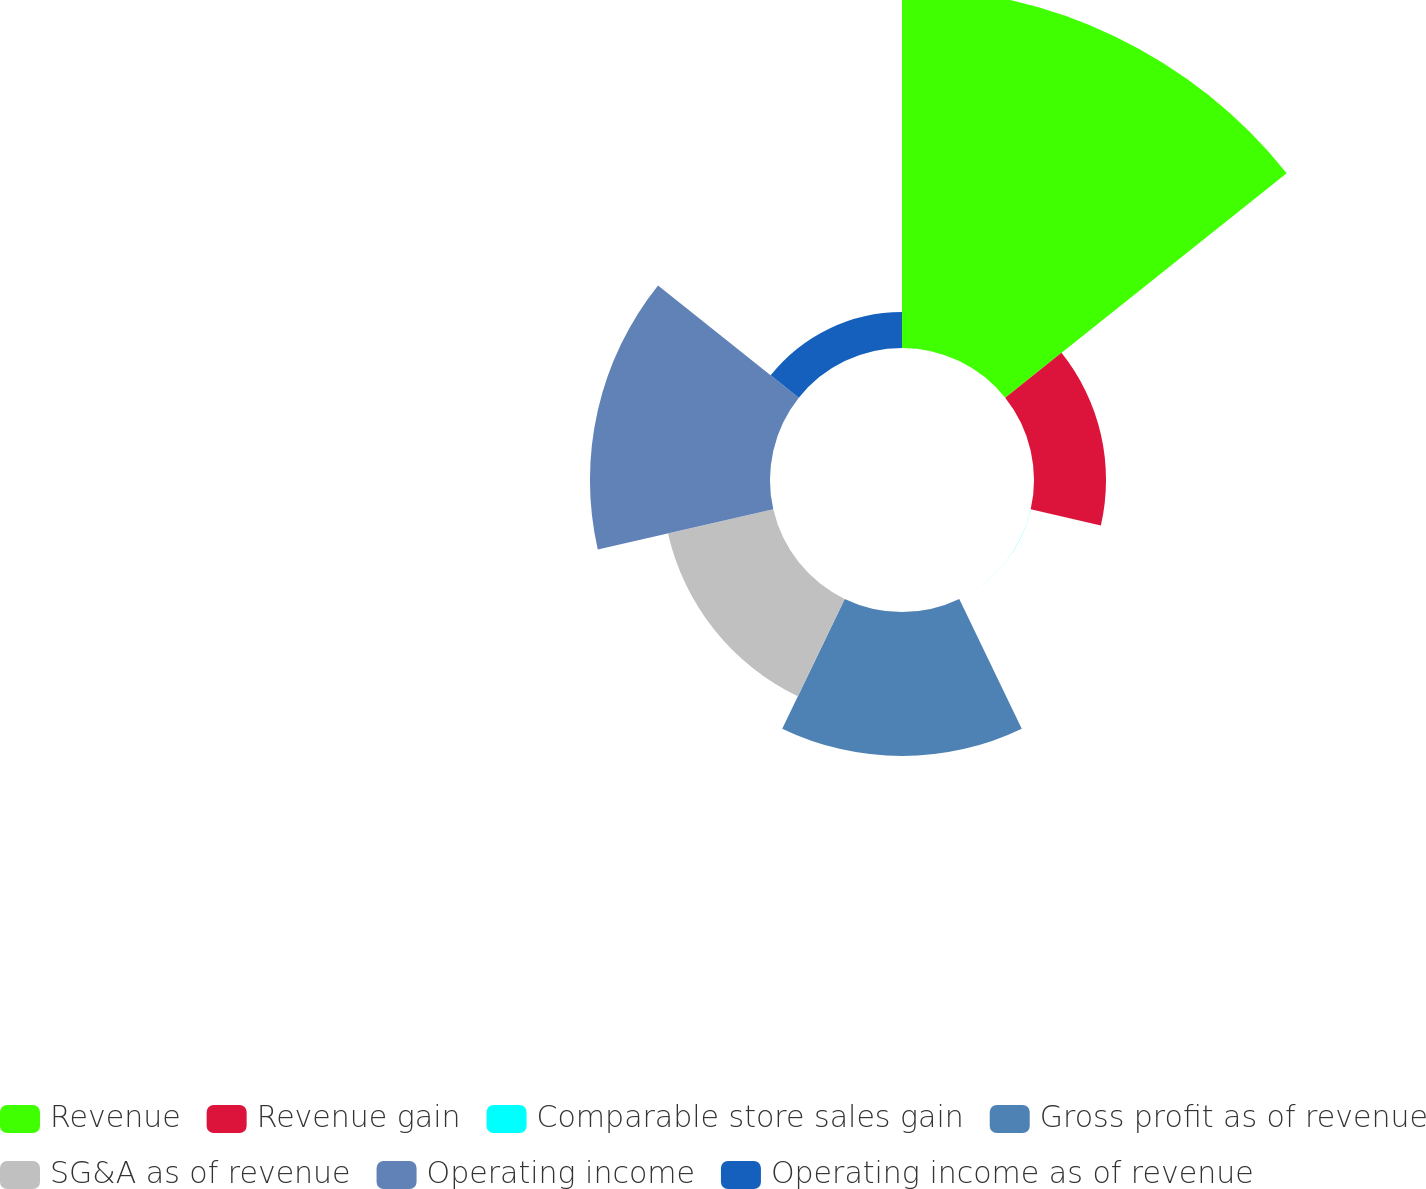Convert chart to OTSL. <chart><loc_0><loc_0><loc_500><loc_500><pie_chart><fcel>Revenue<fcel>Revenue gain<fcel>Comparable store sales gain<fcel>Gross profit as of revenue<fcel>SG&A as of revenue<fcel>Operating income<fcel>Operating income as of revenue<nl><fcel>39.99%<fcel>8.0%<fcel>0.01%<fcel>16.0%<fcel>12.0%<fcel>20.0%<fcel>4.0%<nl></chart> 